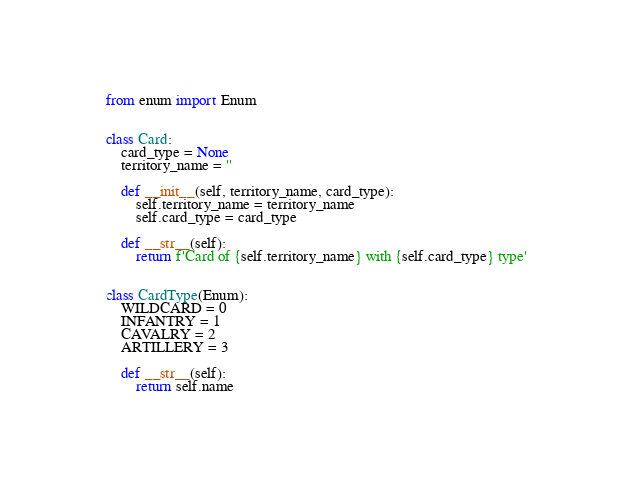Convert code to text. <code><loc_0><loc_0><loc_500><loc_500><_Python_>from enum import Enum


class Card:
    card_type = None
    territory_name = ''

    def __init__(self, territory_name, card_type):
        self.territory_name = territory_name
        self.card_type = card_type

    def __str__(self):
        return f'Card of {self.territory_name} with {self.card_type} type'


class CardType(Enum):
    WILDCARD = 0
    INFANTRY = 1
    CAVALRY = 2
    ARTILLERY = 3

    def __str__(self):
        return self.name
</code> 